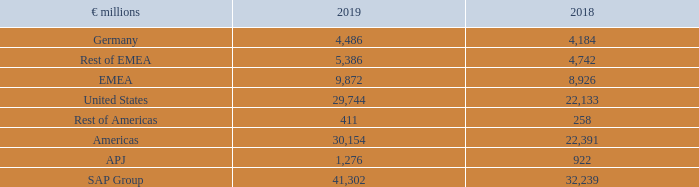(D.6) Non-Current Assets by Region
The table below shows non-current assets excluding financial instruments, deferred tax assets, post-employment benefit assets, and rights arising under insurance contracts.
Non-Current Assets by Region
For a breakdown of our employee headcount by region, see Note (B.1) , and for a breakdown of revenue by region, see Note (A.1) .
What information does the table show? Non-current assets excluding financial instruments, deferred tax assets, post-employment benefit assets, and rights arising under insurance contracts. What was the amount of non-current assets in APJ in 2019?
Answer scale should be: million. 1,276. In which years were the Non-Current Assets by Region calculated? 2019, 2018. In which year was the amount in Rest of Americas larger? 411>258
Answer: 2019. What was the change in the amount in Rest of Americas in 2019 from 2018?
Answer scale should be: million. 411-258
Answer: 153. What was the percentage change in the amount in Rest of Americas in 2019 from 2018?
Answer scale should be: percent. (411-258)/258
Answer: 59.3. 